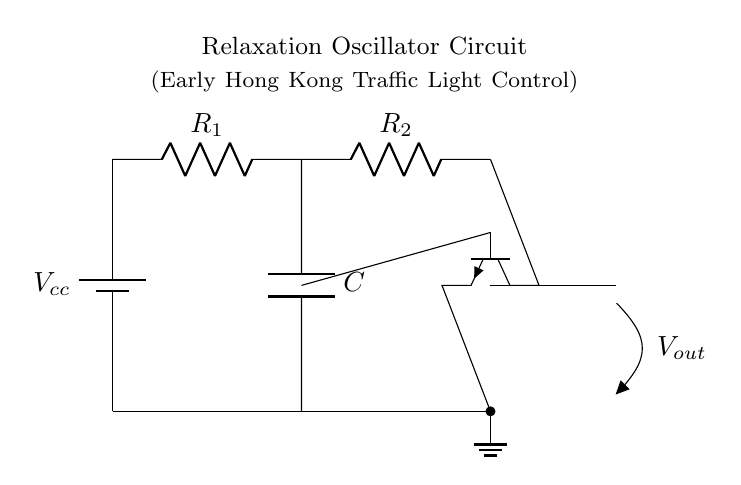What type of transistor is used in this circuit? The circuit diagram shows an NPN transistor, as indicated by the npn symbol at the circuit's center. The shape and labeling confirm its type.
Answer: NPN What does the capacitor in this circuit do? The capacitor stores and releases charge, helping to create the oscillation by allowing current to flow, which controls the timing in the relaxation oscillator.
Answer: Timing What are the resistors in this circuit labeled as? The resistors in the circuit are labeled as R1 and R2, providing resistance that influences the Charging and discharging rate of the capacitor.
Answer: R1, R2 What is the primary function of this circuit in traffic light control? The primary function of this relaxation oscillator circuit is to generate a periodic output signal that is used to control the timing of the traffic lights, allowing them to alternate.
Answer: Timing control Why does the circuit oscillate? The oscillation occurs due to the interplay between the capacitor charging through the resistors and the transistor switching on and off, creating a repeating cycle of charging and discharging that produces the oscillation.
Answer: Interplay of charging and switching How many power supply connections are shown? The circuit diagram shows one power supply connection, indicated by the battery symbol at the left, which provides the necessary voltage for the entire circuit operation.
Answer: One What is the output voltage taken from in this circuit? The output voltage is taken from the collector of the NPN transistor, as shown by the arrow pointing towards the output label, indicating where the oscillation signal can be measured.
Answer: Collector of the NPN 